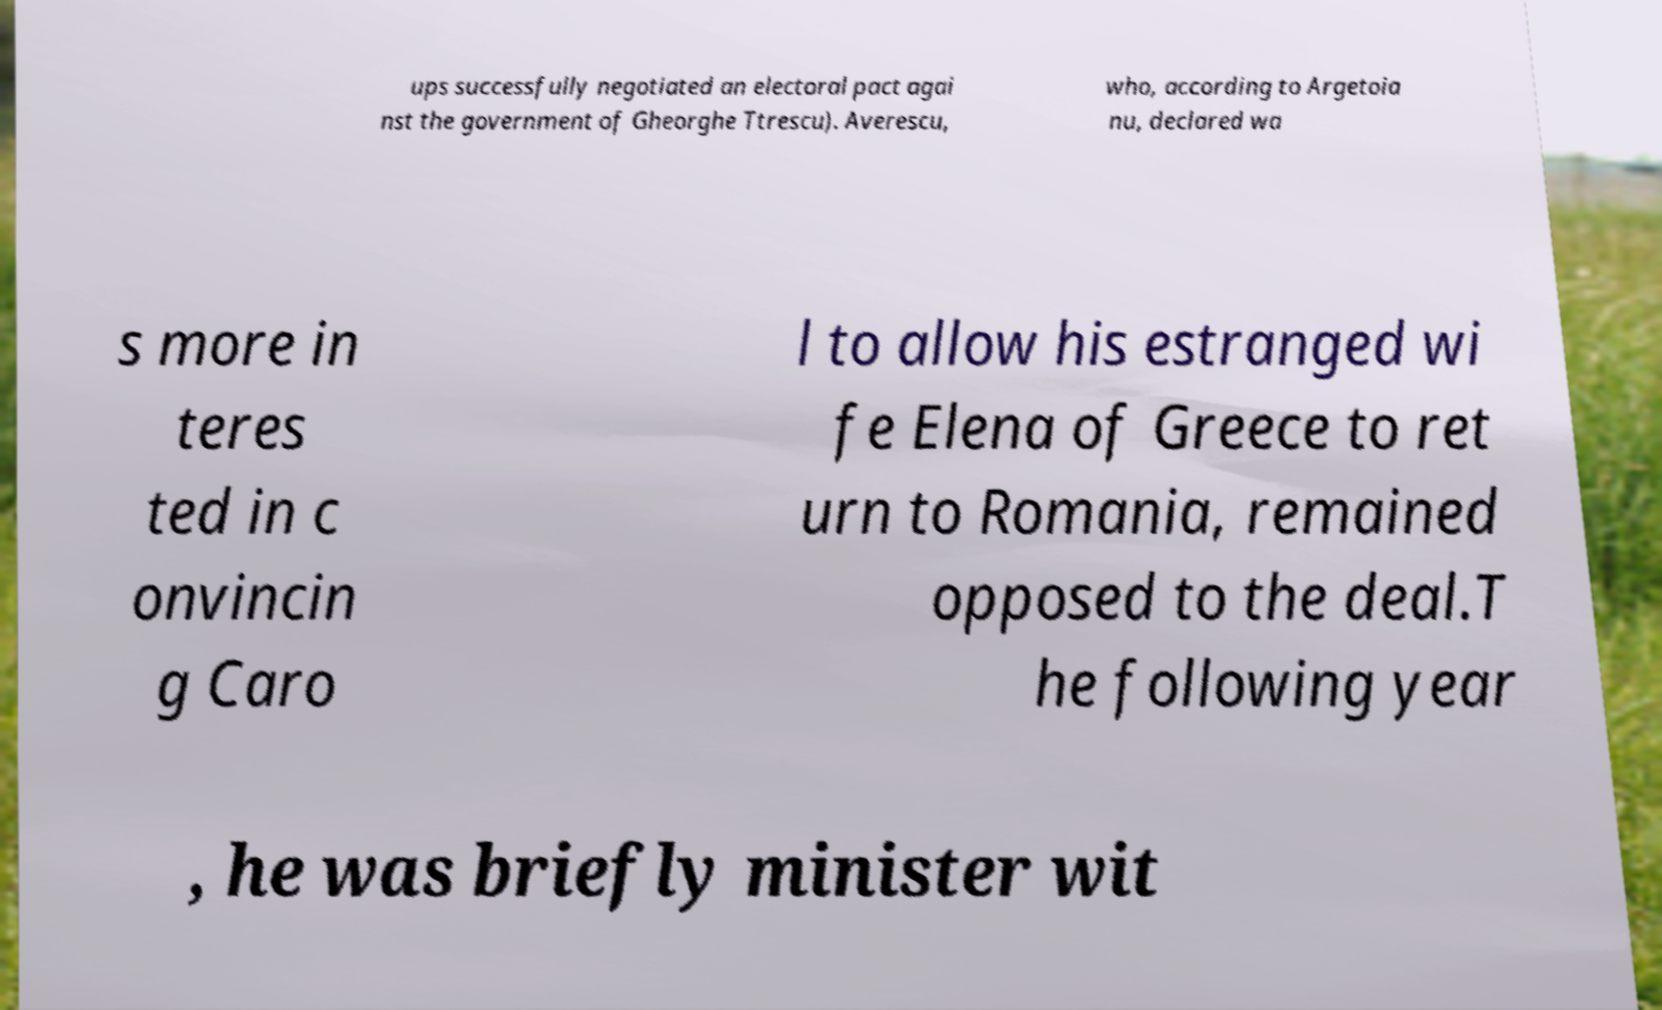Please read and relay the text visible in this image. What does it say? ups successfully negotiated an electoral pact agai nst the government of Gheorghe Ttrescu). Averescu, who, according to Argetoia nu, declared wa s more in teres ted in c onvincin g Caro l to allow his estranged wi fe Elena of Greece to ret urn to Romania, remained opposed to the deal.T he following year , he was briefly minister wit 